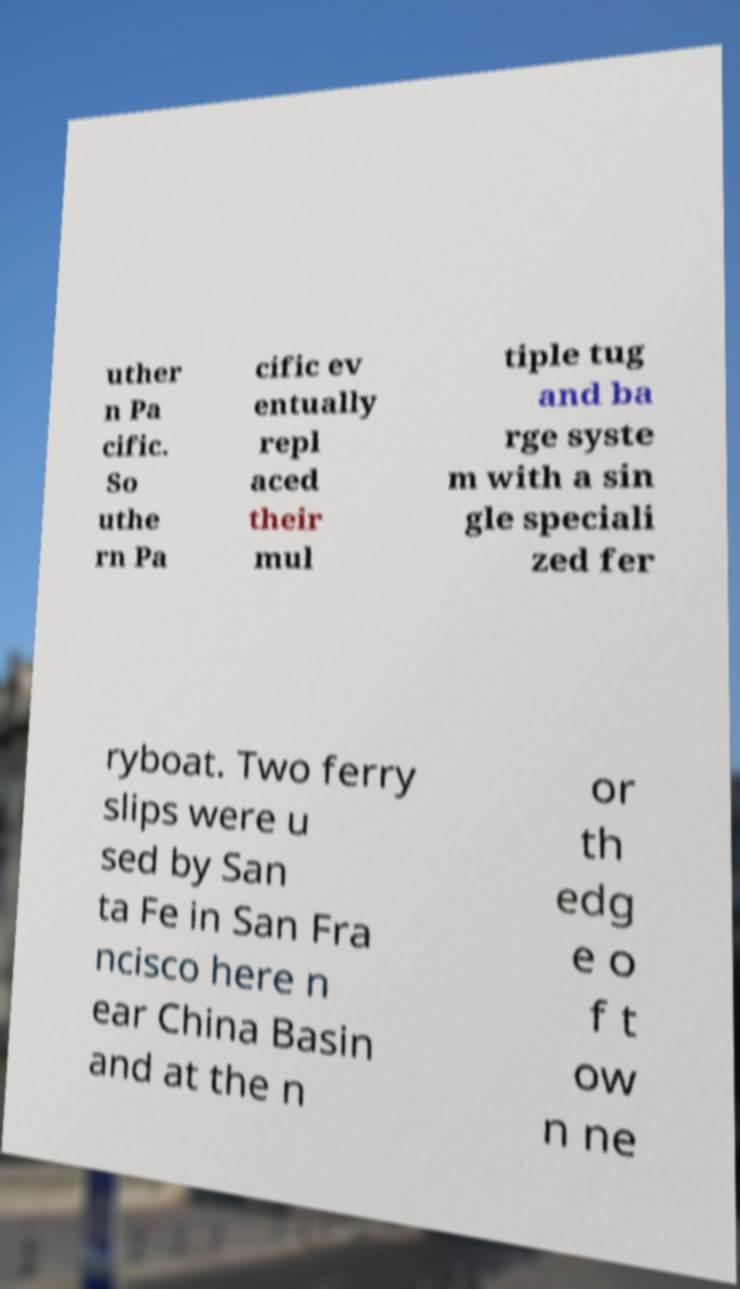Can you accurately transcribe the text from the provided image for me? uther n Pa cific. So uthe rn Pa cific ev entually repl aced their mul tiple tug and ba rge syste m with a sin gle speciali zed fer ryboat. Two ferry slips were u sed by San ta Fe in San Fra ncisco here n ear China Basin and at the n or th edg e o f t ow n ne 